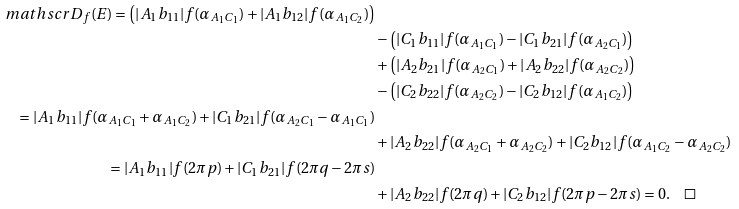Convert formula to latex. <formula><loc_0><loc_0><loc_500><loc_500>\ m a t h s c r D _ { f } ( E ) = \left ( | A _ { 1 } b _ { 1 1 } | f ( \alpha _ { A _ { 1 } C _ { 1 } } ) + | A _ { 1 } b _ { 1 2 } | f ( \alpha _ { A _ { 1 } C _ { 2 } } ) \right ) \\ & - \left ( | C _ { 1 } b _ { 1 1 } | f ( \alpha _ { A _ { 1 } C _ { 1 } } ) - | C _ { 1 } b _ { 2 1 } | f ( \alpha _ { A _ { 2 } C _ { 1 } } ) \right ) \\ & + \left ( | A _ { 2 } b _ { 2 1 } | f ( \alpha _ { A _ { 2 } C _ { 1 } } ) + | A _ { 2 } b _ { 2 2 } | f ( \alpha _ { A _ { 2 } C _ { 2 } } ) \right ) \\ & - \left ( | C _ { 2 } b _ { 2 2 } | f ( \alpha _ { A _ { 2 } C _ { 2 } } ) - | C _ { 2 } b _ { 1 2 } | f ( \alpha _ { A _ { 1 } C _ { 2 } } ) \right ) \\ = | A _ { 1 } b _ { 1 1 } | f ( \alpha _ { A _ { 1 } C _ { 1 } } + \alpha _ { A _ { 1 } C _ { 2 } } ) + | C _ { 1 } b _ { 2 1 } | f ( \alpha _ { A _ { 2 } C _ { 1 } } - \alpha _ { A _ { 1 } C _ { 1 } } ) \\ & + | A _ { 2 } b _ { 2 2 } | f ( \alpha _ { A _ { 2 } C _ { 1 } } + \alpha _ { A _ { 2 } C _ { 2 } } ) + | C _ { 2 } b _ { 1 2 } | f ( \alpha _ { A _ { 1 } C _ { 2 } } - \alpha _ { A _ { 2 } C _ { 2 } } ) \\ = | A _ { 1 } b _ { 1 1 } | f ( 2 \pi p ) + | C _ { 1 } b _ { 2 1 } | f ( 2 \pi q - 2 \pi s ) \\ & + | A _ { 2 } b _ { 2 2 } | f ( 2 \pi q ) + | C _ { 2 } b _ { 1 2 } | f ( 2 \pi p - 2 \pi s ) = 0 . \quad \square</formula> 